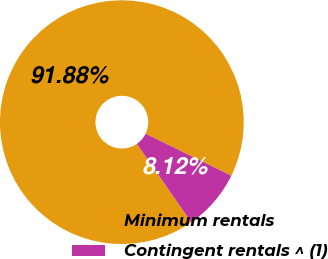<chart> <loc_0><loc_0><loc_500><loc_500><pie_chart><fcel>Minimum rentals<fcel>Contingent rentals ^ (1)<nl><fcel>91.88%<fcel>8.12%<nl></chart> 